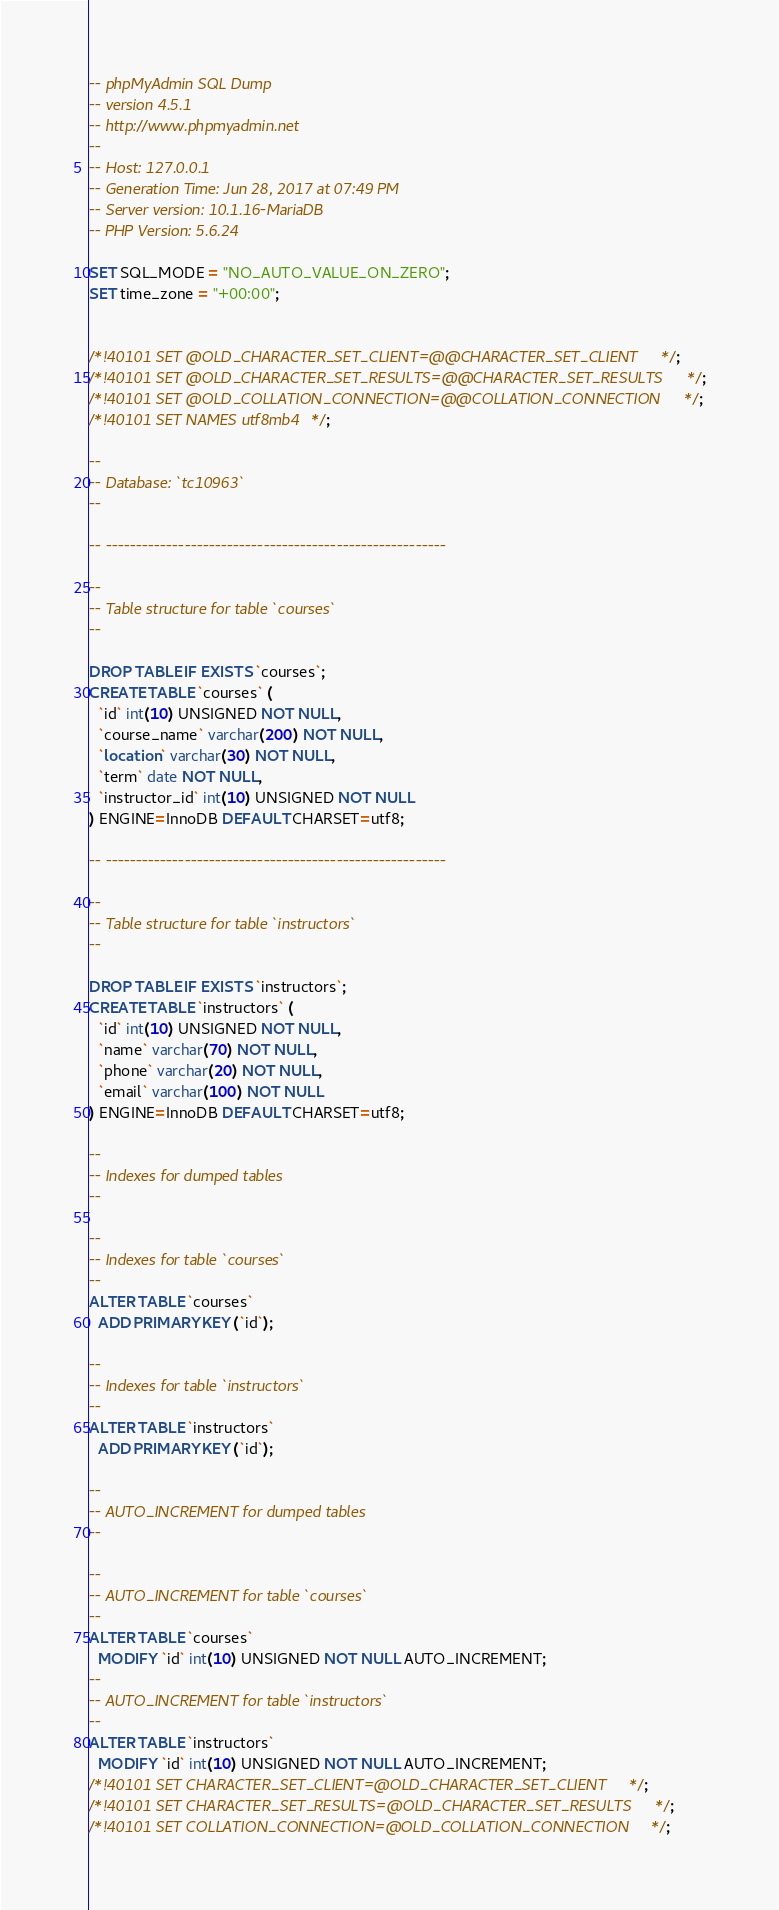Convert code to text. <code><loc_0><loc_0><loc_500><loc_500><_SQL_>-- phpMyAdmin SQL Dump
-- version 4.5.1
-- http://www.phpmyadmin.net
--
-- Host: 127.0.0.1
-- Generation Time: Jun 28, 2017 at 07:49 PM
-- Server version: 10.1.16-MariaDB
-- PHP Version: 5.6.24

SET SQL_MODE = "NO_AUTO_VALUE_ON_ZERO";
SET time_zone = "+00:00";


/*!40101 SET @OLD_CHARACTER_SET_CLIENT=@@CHARACTER_SET_CLIENT */;
/*!40101 SET @OLD_CHARACTER_SET_RESULTS=@@CHARACTER_SET_RESULTS */;
/*!40101 SET @OLD_COLLATION_CONNECTION=@@COLLATION_CONNECTION */;
/*!40101 SET NAMES utf8mb4 */;

--
-- Database: `tc10963`
--

-- --------------------------------------------------------

--
-- Table structure for table `courses`
--

DROP TABLE IF EXISTS `courses`;
CREATE TABLE `courses` (
  `id` int(10) UNSIGNED NOT NULL,
  `course_name` varchar(200) NOT NULL,
  `location` varchar(30) NOT NULL,
  `term` date NOT NULL,
  `instructor_id` int(10) UNSIGNED NOT NULL
) ENGINE=InnoDB DEFAULT CHARSET=utf8;

-- --------------------------------------------------------

--
-- Table structure for table `instructors`
--

DROP TABLE IF EXISTS `instructors`;
CREATE TABLE `instructors` (
  `id` int(10) UNSIGNED NOT NULL,
  `name` varchar(70) NOT NULL,
  `phone` varchar(20) NOT NULL,
  `email` varchar(100) NOT NULL
) ENGINE=InnoDB DEFAULT CHARSET=utf8;

--
-- Indexes for dumped tables
--

--
-- Indexes for table `courses`
--
ALTER TABLE `courses`
  ADD PRIMARY KEY (`id`);

--
-- Indexes for table `instructors`
--
ALTER TABLE `instructors`
  ADD PRIMARY KEY (`id`);

--
-- AUTO_INCREMENT for dumped tables
--

--
-- AUTO_INCREMENT for table `courses`
--
ALTER TABLE `courses`
  MODIFY `id` int(10) UNSIGNED NOT NULL AUTO_INCREMENT;
--
-- AUTO_INCREMENT for table `instructors`
--
ALTER TABLE `instructors`
  MODIFY `id` int(10) UNSIGNED NOT NULL AUTO_INCREMENT;
/*!40101 SET CHARACTER_SET_CLIENT=@OLD_CHARACTER_SET_CLIENT */;
/*!40101 SET CHARACTER_SET_RESULTS=@OLD_CHARACTER_SET_RESULTS */;
/*!40101 SET COLLATION_CONNECTION=@OLD_COLLATION_CONNECTION */;
</code> 